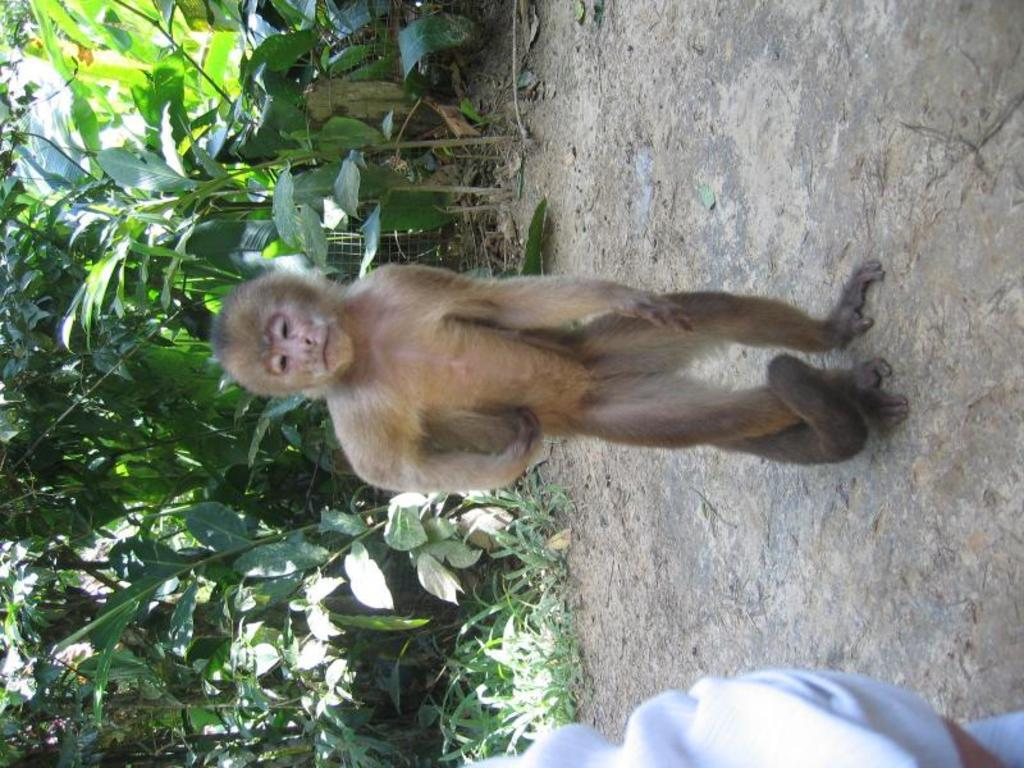What type of animal is in the image? There is a monkey in the image. What other living organisms can be seen in the image? There are plants in the image. What type of vegetation is present in the image? There is grass in the image. What type of comb is the monkey using to groom the plants in the image? There is no comb present in the image, and the monkey is not grooming the plants. 